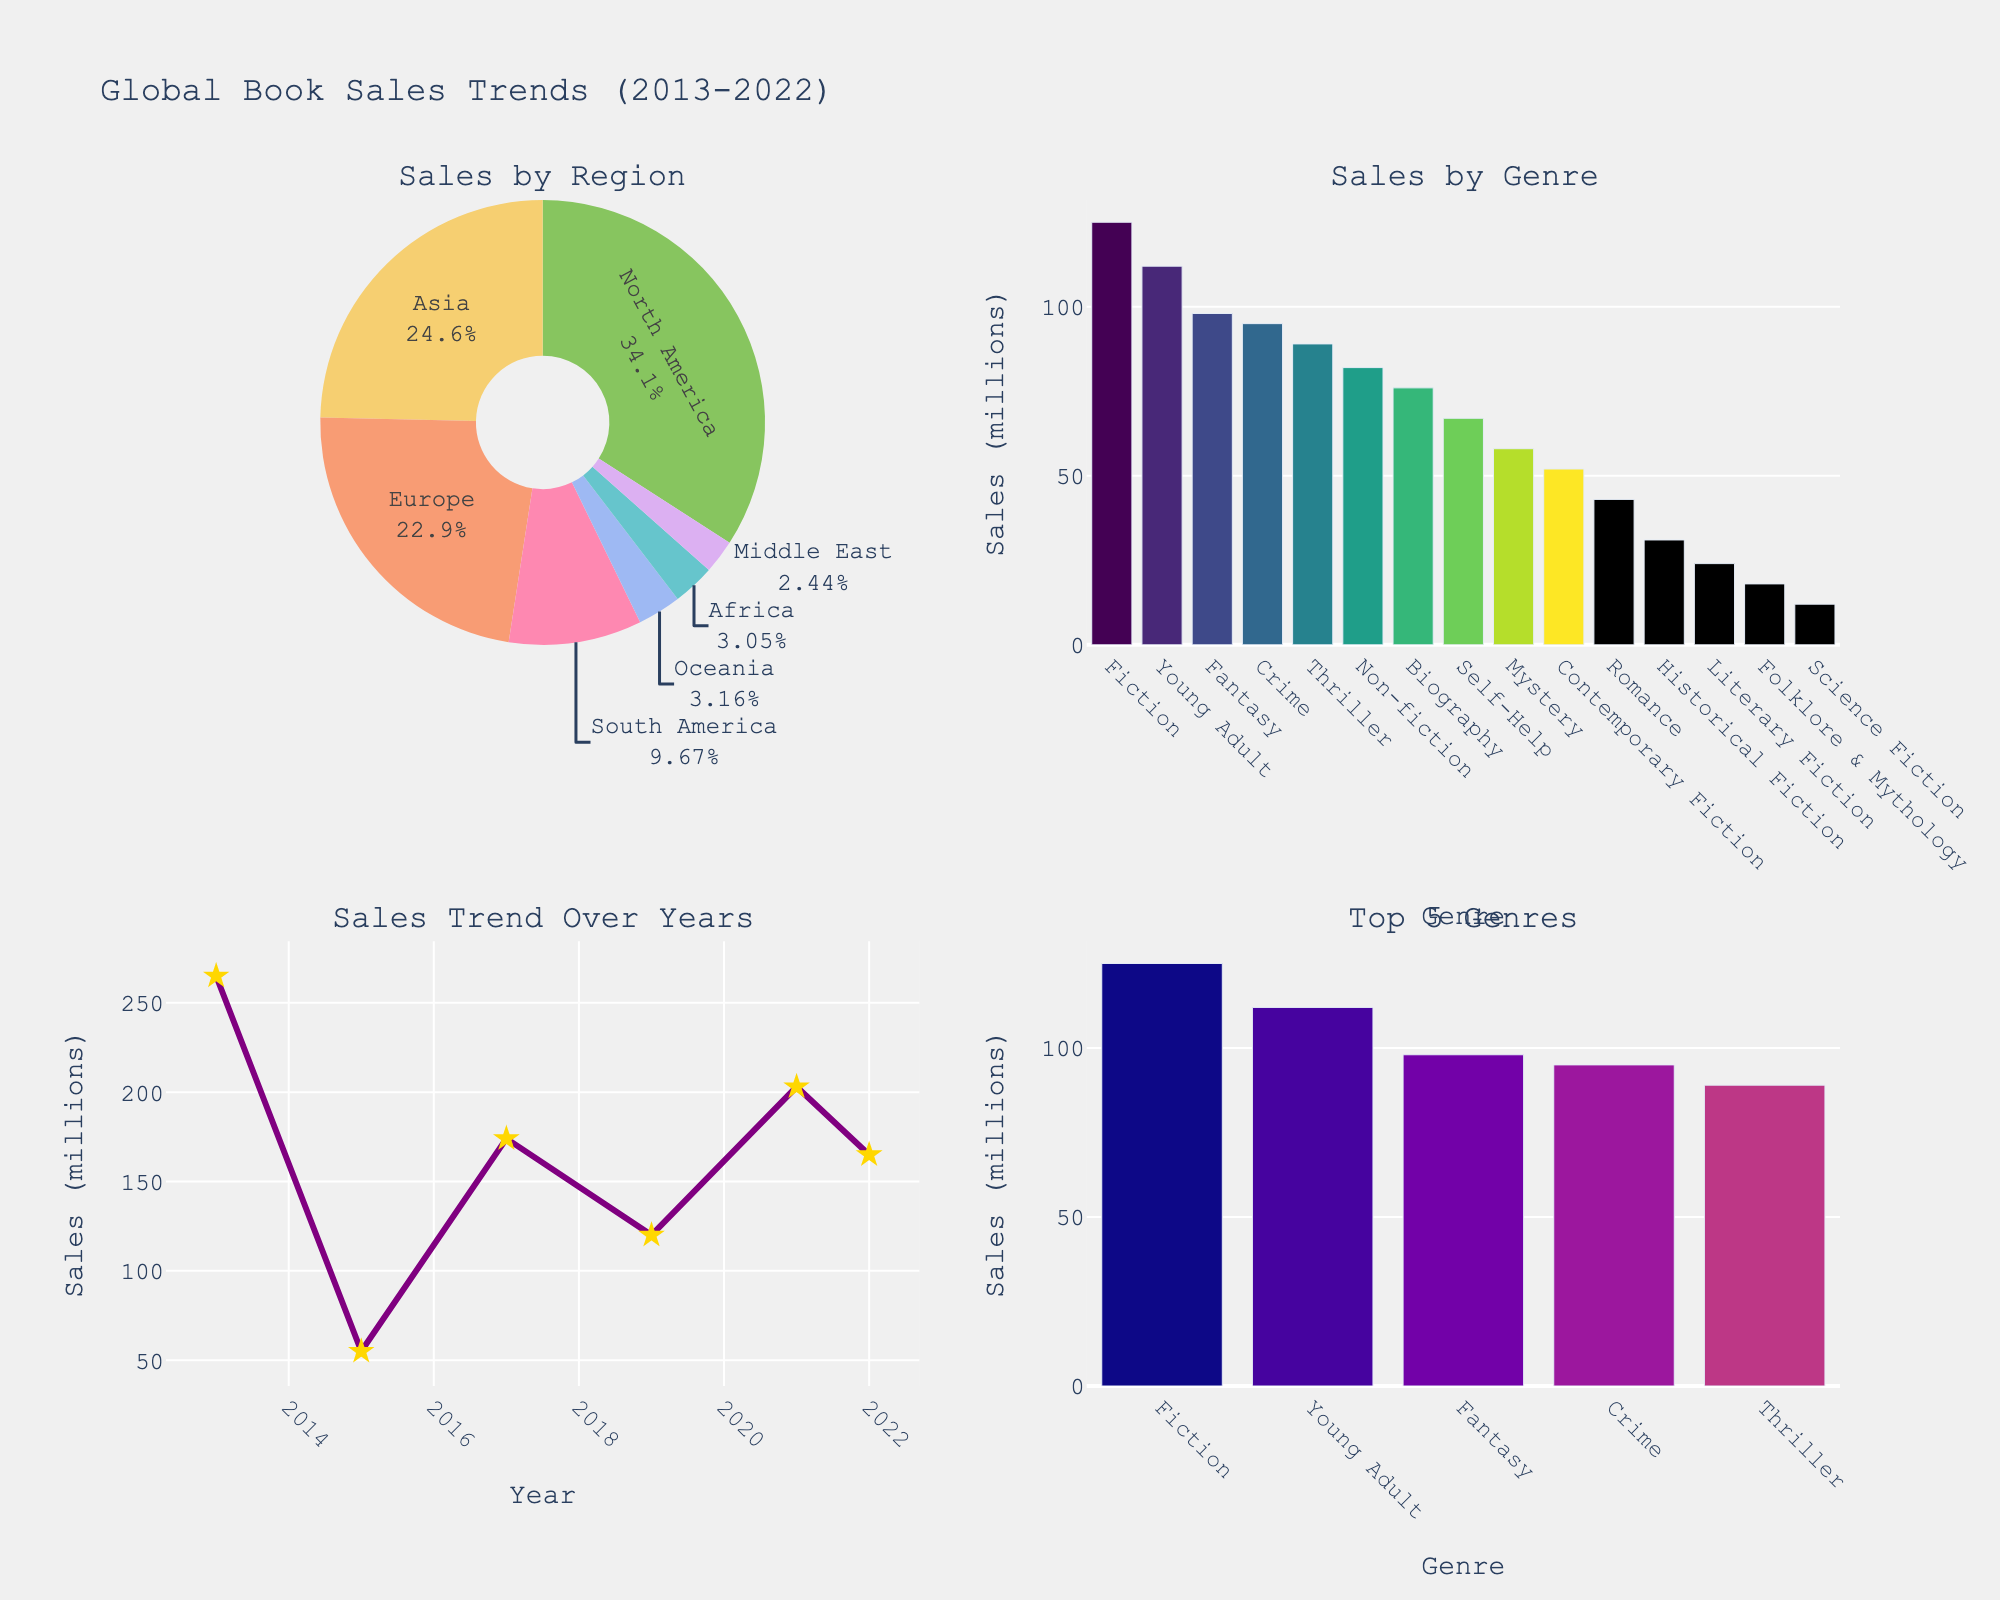What's the overall trend in global book sales from 2013 to 2022? Observing the scatter plot in the bottom left quadrant, the line chart depicting sales over years shows an increasing trend, with a noticeable peak around 2019 and 2021.
Answer: Increasing Which region has the highest total book sales? In the pie chart on the top left quadrant, North America occupies the largest slice, indicating it has the highest total book sales.
Answer: North America What are the top 5 genres in terms of sales? The bar chart in the bottom right quadrant shows the top 5 genres by sales. Observing the bars, the top genres are Fiction, Young Adult, Mystery, Fantasy, and Thriller.
Answer: Fiction, Young Adult, Mystery, Fantasy, Thriller How do sales of Fiction compare to those of Science Fiction? In the bar chart in the top right quadrant, Fiction has a much higher bar than Science Fiction, indicating significantly higher sales.
Answer: Fiction has higher sales What year saw the highest book sales? Examining the line chart for the sales trend over years in the bottom left quadrant, the peak sales are around the year 2021.
Answer: 2021 Which genres have shown up once in the past decade? From the bar charts and the data labels, genres such as Contemporary Fiction and Folklore & Mythology are shown once on the plot.
Answer: Contemporary Fiction, Folklore & Mythology What percentage of the total sales does Europe's book market represent? In the pie chart on the top left, Europe’s segment shows its percentage of the total. According to the labels, Europe makes up roughly 18% of the total sales.
Answer: ~18% What is the approximate total sales for Young Adult books across all regions? The bar chart in the top right quadrant shows Young Adult sales. The height of the bar approximates sales at around 112 million.
Answer: 112 million Which genre had the lowest sales in 2021? Referring to the dataset and the bar charts plotted, Literary Fiction in the Middle East shows the lowest sales around 24 million in 2021.
Answer: Literary Fiction Which year had the lowest overall book sales from 2013 to 2022? Observing the line chart for overall sales by year in the bottom left quadrant, 2015 manifests as the dip, indicating the lowest sales.
Answer: 2015 